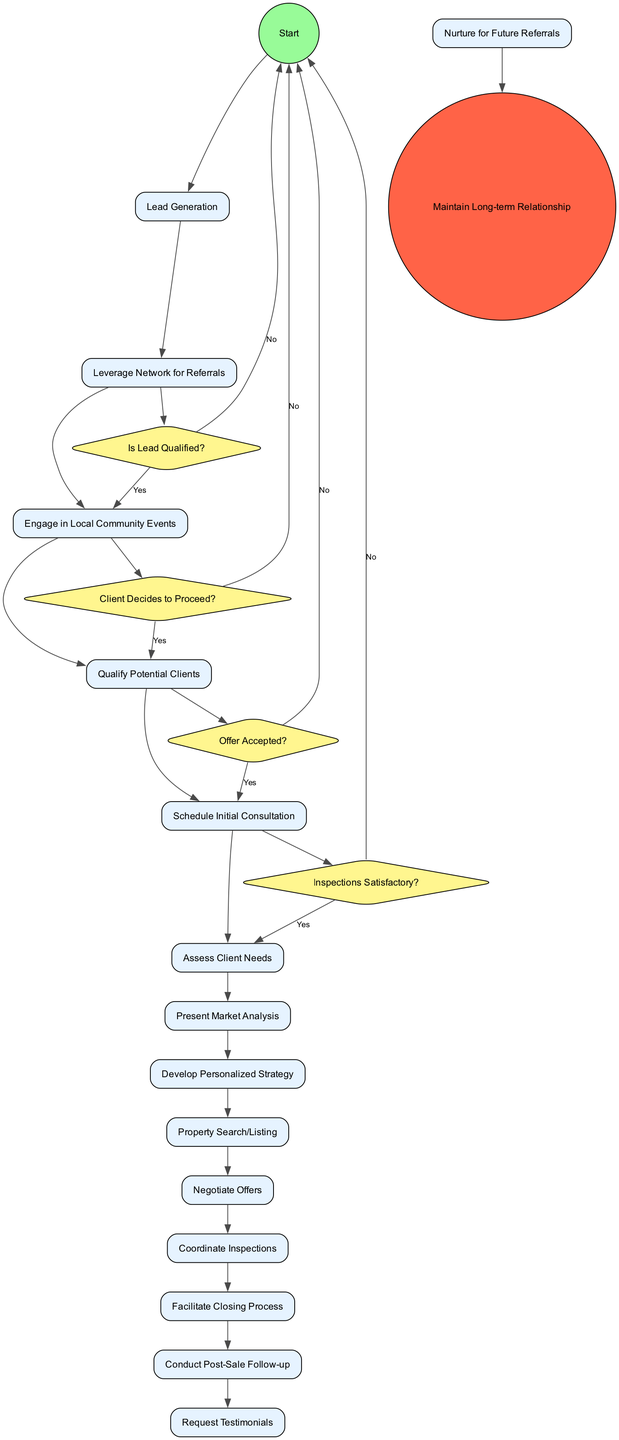What is the initial node of the diagram? The diagram starts with the node labeled "Lead Generation." This is indicated as the first activity that follows the initial start node and serves as the foundation for the client's lifecycle.
Answer: Lead Generation How many activities are represented in the diagram? The diagram presents 13 distinct activities. By counting each individual activity node listed, we identify the total number of activities in the lifecycle process.
Answer: 13 What decision follows the activity "Present Market Analysis"? The "Present Market Analysis" activity leads to the decision node labeled "Client Decides to Proceed?" This decision checks if the client wants to continue after the market analysis.
Answer: Client Decides to Proceed? How many decision nodes are present in the diagram? There are four decision nodes in the diagram. Each decision node corresponds to a specific point in the process where a yes or no answer leads to different pathways.
Answer: 4 What is the last activity before reaching the final node? The last activity before the final node is "Nurture for Future Referrals." This activity occurs just before the process concludes with the maintenance of a long-term relationship at the final node.
Answer: Nurture for Future Referrals If a lead is not qualified, what is the next step in the diagram? If the lead is not qualified, the flow returns to the start node. This indicates that the process will not proceed with that lead and restarts the initial generation of leads.
Answer: Start What is the relationship between "Negotiate Offers" and "Coordinate Inspections"? "Negotiate Offers" leads directly to "Coordinate Inspections." This flow indicates that once an offer is negotiated, the next step is to coordinate property inspections as part of the process.
Answer: Coordinate Inspections What is the final node of the diagram? The final node of the diagram is labeled as "Maintain Long-term Relationship." This encapsulates the end goal of the lifecycle process after all activities and decisions have been navigated successfully.
Answer: Maintain Long-term Relationship 